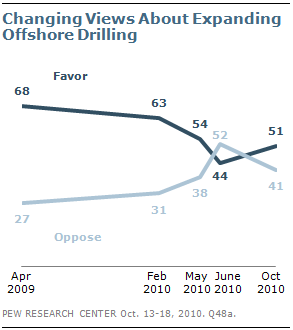List a handful of essential elements in this visual. We need to find the average of all the "Oppose" data points that are below 40. The current number is 32. In May 2010, the favor and oppose lines for a particular subject intersected. 